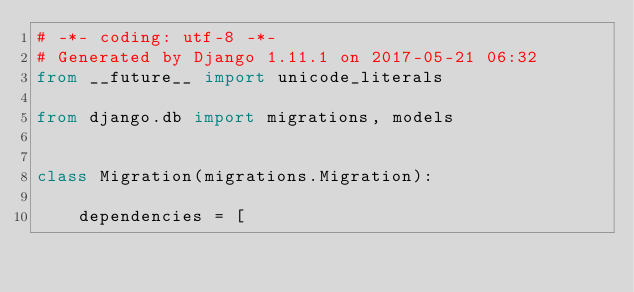Convert code to text. <code><loc_0><loc_0><loc_500><loc_500><_Python_># -*- coding: utf-8 -*-
# Generated by Django 1.11.1 on 2017-05-21 06:32
from __future__ import unicode_literals

from django.db import migrations, models


class Migration(migrations.Migration):

    dependencies = [</code> 